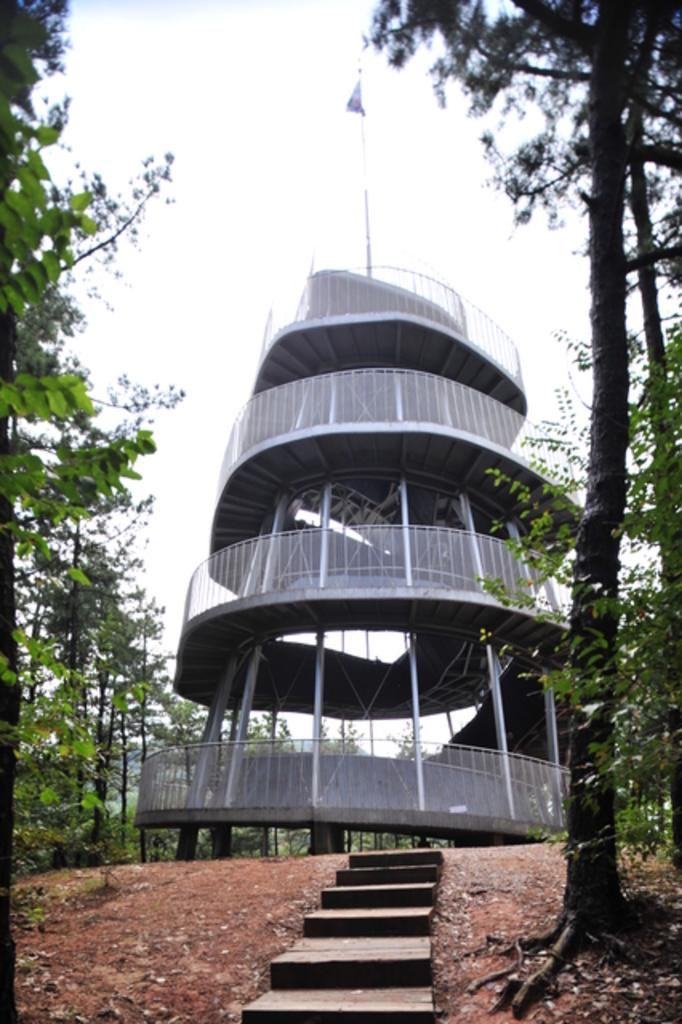What type of structure is in the image? There is a building in the image. What natural elements can be seen in the image? There are trees in the image. What is on the ground in the image? Dried leaves are present on the ground. What is attached to the pole in the image? A flag is attached to the pole in the image. What architectural feature is visible in the image? A staircase is visible in the image. What can be seen in the background of the image? The sky is visible in the background of the image. What type of glue is being used to create the art in the image? There is no art or glue present in the image; it features a building, trees, dried leaves, a pole with a flag, a staircase, and the sky. 